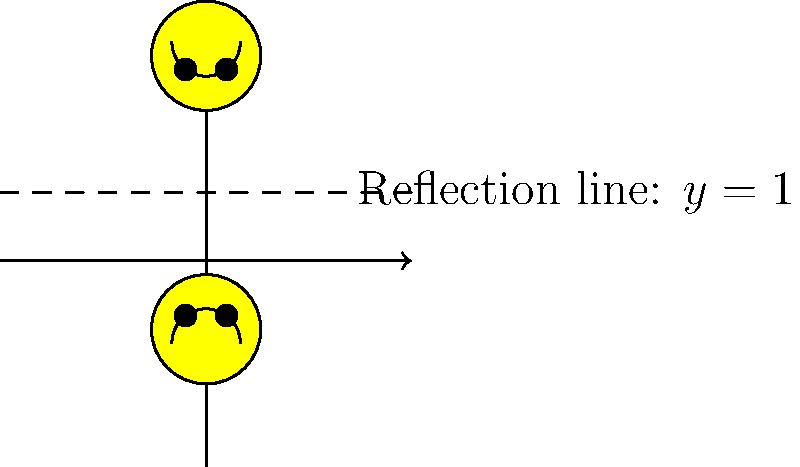Hey, check out this cool smiley face emoji I drew! I reflected it across the line $y=1$. Can you tell me what the y-coordinate of the center of the reflected smiley face would be? Let's think about this step-by-step:

1. The original smiley face is centered at $(0,-1)$.
2. The reflection line is $y=1$.
3. To reflect a point across a horizontal line, we keep the x-coordinate the same and calculate the new y-coordinate.
4. The distance from the original point to the reflection line is $1 - (-1) = 2$.
5. The reflected point will be this same distance above the reflection line.
6. So, we add 2 to the y-coordinate of the reflection line: $1 + 2 = 3$.

Therefore, the center of the reflected smiley face will be at $(0,3)$.
Answer: 3 